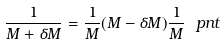<formula> <loc_0><loc_0><loc_500><loc_500>\frac { 1 } { M + \delta M } = \frac { 1 } { M } ( M - \delta M ) \frac { 1 } { M } \ p n t</formula> 